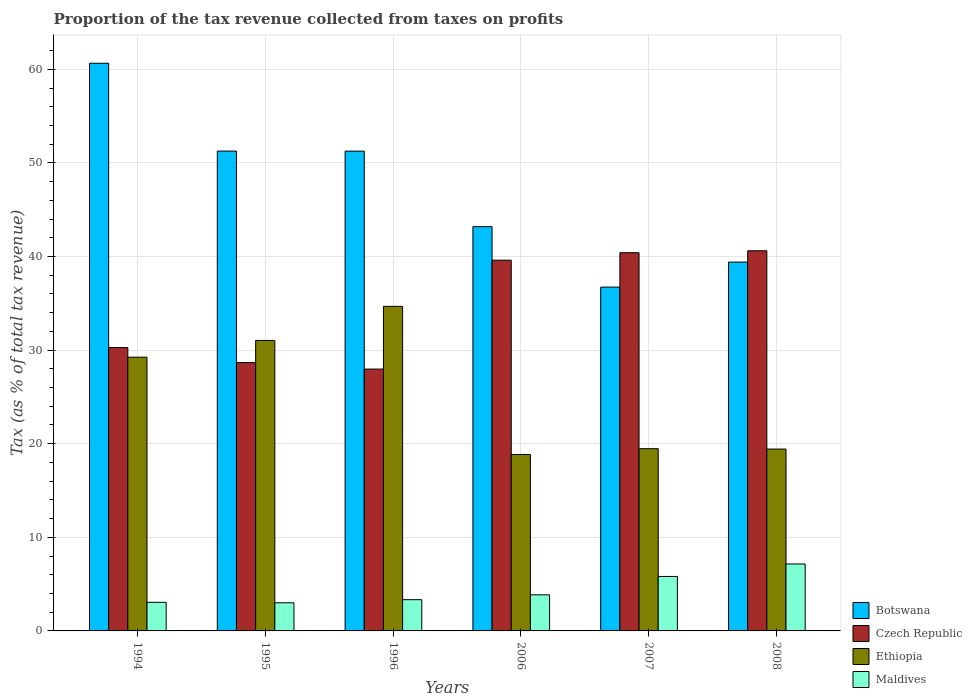How many groups of bars are there?
Give a very brief answer. 6. Are the number of bars per tick equal to the number of legend labels?
Give a very brief answer. Yes. How many bars are there on the 3rd tick from the left?
Offer a very short reply. 4. How many bars are there on the 3rd tick from the right?
Keep it short and to the point. 4. In how many cases, is the number of bars for a given year not equal to the number of legend labels?
Ensure brevity in your answer.  0. What is the proportion of the tax revenue collected in Ethiopia in 2006?
Provide a short and direct response. 18.85. Across all years, what is the maximum proportion of the tax revenue collected in Botswana?
Your answer should be very brief. 60.64. Across all years, what is the minimum proportion of the tax revenue collected in Maldives?
Offer a terse response. 3.01. In which year was the proportion of the tax revenue collected in Maldives maximum?
Make the answer very short. 2008. What is the total proportion of the tax revenue collected in Botswana in the graph?
Give a very brief answer. 282.48. What is the difference between the proportion of the tax revenue collected in Czech Republic in 1996 and that in 2006?
Ensure brevity in your answer.  -11.64. What is the difference between the proportion of the tax revenue collected in Maldives in 2008 and the proportion of the tax revenue collected in Ethiopia in 2006?
Provide a succinct answer. -11.7. What is the average proportion of the tax revenue collected in Ethiopia per year?
Ensure brevity in your answer.  25.45. In the year 1995, what is the difference between the proportion of the tax revenue collected in Ethiopia and proportion of the tax revenue collected in Botswana?
Make the answer very short. -20.23. What is the ratio of the proportion of the tax revenue collected in Ethiopia in 1994 to that in 1995?
Provide a short and direct response. 0.94. Is the proportion of the tax revenue collected in Czech Republic in 1994 less than that in 1996?
Provide a short and direct response. No. What is the difference between the highest and the second highest proportion of the tax revenue collected in Botswana?
Give a very brief answer. 9.38. What is the difference between the highest and the lowest proportion of the tax revenue collected in Czech Republic?
Provide a short and direct response. 12.64. Is the sum of the proportion of the tax revenue collected in Ethiopia in 1995 and 2006 greater than the maximum proportion of the tax revenue collected in Maldives across all years?
Provide a short and direct response. Yes. What does the 4th bar from the left in 2008 represents?
Your answer should be very brief. Maldives. What does the 1st bar from the right in 1994 represents?
Offer a terse response. Maldives. Is it the case that in every year, the sum of the proportion of the tax revenue collected in Maldives and proportion of the tax revenue collected in Czech Republic is greater than the proportion of the tax revenue collected in Ethiopia?
Provide a short and direct response. No. How many bars are there?
Make the answer very short. 24. How many years are there in the graph?
Your answer should be compact. 6. What is the difference between two consecutive major ticks on the Y-axis?
Ensure brevity in your answer.  10. Does the graph contain any zero values?
Provide a succinct answer. No. Does the graph contain grids?
Ensure brevity in your answer.  Yes. How many legend labels are there?
Offer a very short reply. 4. How are the legend labels stacked?
Your response must be concise. Vertical. What is the title of the graph?
Keep it short and to the point. Proportion of the tax revenue collected from taxes on profits. What is the label or title of the X-axis?
Offer a very short reply. Years. What is the label or title of the Y-axis?
Offer a very short reply. Tax (as % of total tax revenue). What is the Tax (as % of total tax revenue) in Botswana in 1994?
Provide a short and direct response. 60.64. What is the Tax (as % of total tax revenue) of Czech Republic in 1994?
Your response must be concise. 30.27. What is the Tax (as % of total tax revenue) of Ethiopia in 1994?
Your answer should be compact. 29.24. What is the Tax (as % of total tax revenue) in Maldives in 1994?
Offer a very short reply. 3.06. What is the Tax (as % of total tax revenue) in Botswana in 1995?
Make the answer very short. 51.26. What is the Tax (as % of total tax revenue) in Czech Republic in 1995?
Keep it short and to the point. 28.66. What is the Tax (as % of total tax revenue) in Ethiopia in 1995?
Offer a terse response. 31.03. What is the Tax (as % of total tax revenue) of Maldives in 1995?
Your answer should be very brief. 3.01. What is the Tax (as % of total tax revenue) in Botswana in 1996?
Give a very brief answer. 51.26. What is the Tax (as % of total tax revenue) in Czech Republic in 1996?
Ensure brevity in your answer.  27.97. What is the Tax (as % of total tax revenue) of Ethiopia in 1996?
Your answer should be compact. 34.67. What is the Tax (as % of total tax revenue) of Maldives in 1996?
Your answer should be compact. 3.34. What is the Tax (as % of total tax revenue) of Botswana in 2006?
Your answer should be compact. 43.19. What is the Tax (as % of total tax revenue) in Czech Republic in 2006?
Ensure brevity in your answer.  39.61. What is the Tax (as % of total tax revenue) in Ethiopia in 2006?
Provide a succinct answer. 18.85. What is the Tax (as % of total tax revenue) of Maldives in 2006?
Offer a very short reply. 3.86. What is the Tax (as % of total tax revenue) of Botswana in 2007?
Provide a succinct answer. 36.73. What is the Tax (as % of total tax revenue) of Czech Republic in 2007?
Your answer should be compact. 40.4. What is the Tax (as % of total tax revenue) in Ethiopia in 2007?
Make the answer very short. 19.47. What is the Tax (as % of total tax revenue) in Maldives in 2007?
Provide a short and direct response. 5.82. What is the Tax (as % of total tax revenue) in Botswana in 2008?
Keep it short and to the point. 39.4. What is the Tax (as % of total tax revenue) in Czech Republic in 2008?
Make the answer very short. 40.61. What is the Tax (as % of total tax revenue) of Ethiopia in 2008?
Your answer should be very brief. 19.43. What is the Tax (as % of total tax revenue) of Maldives in 2008?
Keep it short and to the point. 7.15. Across all years, what is the maximum Tax (as % of total tax revenue) in Botswana?
Your answer should be very brief. 60.64. Across all years, what is the maximum Tax (as % of total tax revenue) in Czech Republic?
Your answer should be compact. 40.61. Across all years, what is the maximum Tax (as % of total tax revenue) in Ethiopia?
Offer a very short reply. 34.67. Across all years, what is the maximum Tax (as % of total tax revenue) in Maldives?
Ensure brevity in your answer.  7.15. Across all years, what is the minimum Tax (as % of total tax revenue) of Botswana?
Ensure brevity in your answer.  36.73. Across all years, what is the minimum Tax (as % of total tax revenue) of Czech Republic?
Keep it short and to the point. 27.97. Across all years, what is the minimum Tax (as % of total tax revenue) of Ethiopia?
Give a very brief answer. 18.85. Across all years, what is the minimum Tax (as % of total tax revenue) in Maldives?
Offer a very short reply. 3.01. What is the total Tax (as % of total tax revenue) in Botswana in the graph?
Offer a terse response. 282.48. What is the total Tax (as % of total tax revenue) of Czech Republic in the graph?
Give a very brief answer. 207.53. What is the total Tax (as % of total tax revenue) in Ethiopia in the graph?
Your response must be concise. 152.69. What is the total Tax (as % of total tax revenue) in Maldives in the graph?
Offer a terse response. 26.23. What is the difference between the Tax (as % of total tax revenue) in Botswana in 1994 and that in 1995?
Your answer should be compact. 9.38. What is the difference between the Tax (as % of total tax revenue) in Czech Republic in 1994 and that in 1995?
Your response must be concise. 1.61. What is the difference between the Tax (as % of total tax revenue) in Ethiopia in 1994 and that in 1995?
Your answer should be very brief. -1.79. What is the difference between the Tax (as % of total tax revenue) of Maldives in 1994 and that in 1995?
Keep it short and to the point. 0.05. What is the difference between the Tax (as % of total tax revenue) in Botswana in 1994 and that in 1996?
Give a very brief answer. 9.39. What is the difference between the Tax (as % of total tax revenue) of Czech Republic in 1994 and that in 1996?
Your answer should be very brief. 2.3. What is the difference between the Tax (as % of total tax revenue) of Ethiopia in 1994 and that in 1996?
Ensure brevity in your answer.  -5.43. What is the difference between the Tax (as % of total tax revenue) of Maldives in 1994 and that in 1996?
Provide a short and direct response. -0.28. What is the difference between the Tax (as % of total tax revenue) of Botswana in 1994 and that in 2006?
Your answer should be very brief. 17.46. What is the difference between the Tax (as % of total tax revenue) in Czech Republic in 1994 and that in 2006?
Provide a succinct answer. -9.34. What is the difference between the Tax (as % of total tax revenue) of Ethiopia in 1994 and that in 2006?
Give a very brief answer. 10.39. What is the difference between the Tax (as % of total tax revenue) in Maldives in 1994 and that in 2006?
Your answer should be compact. -0.8. What is the difference between the Tax (as % of total tax revenue) of Botswana in 1994 and that in 2007?
Your answer should be very brief. 23.91. What is the difference between the Tax (as % of total tax revenue) in Czech Republic in 1994 and that in 2007?
Provide a short and direct response. -10.13. What is the difference between the Tax (as % of total tax revenue) in Ethiopia in 1994 and that in 2007?
Provide a short and direct response. 9.77. What is the difference between the Tax (as % of total tax revenue) in Maldives in 1994 and that in 2007?
Keep it short and to the point. -2.76. What is the difference between the Tax (as % of total tax revenue) in Botswana in 1994 and that in 2008?
Provide a succinct answer. 21.24. What is the difference between the Tax (as % of total tax revenue) in Czech Republic in 1994 and that in 2008?
Ensure brevity in your answer.  -10.34. What is the difference between the Tax (as % of total tax revenue) of Ethiopia in 1994 and that in 2008?
Provide a short and direct response. 9.81. What is the difference between the Tax (as % of total tax revenue) of Maldives in 1994 and that in 2008?
Your answer should be very brief. -4.09. What is the difference between the Tax (as % of total tax revenue) of Botswana in 1995 and that in 1996?
Give a very brief answer. 0.01. What is the difference between the Tax (as % of total tax revenue) in Czech Republic in 1995 and that in 1996?
Your answer should be compact. 0.69. What is the difference between the Tax (as % of total tax revenue) in Ethiopia in 1995 and that in 1996?
Keep it short and to the point. -3.64. What is the difference between the Tax (as % of total tax revenue) in Maldives in 1995 and that in 1996?
Ensure brevity in your answer.  -0.33. What is the difference between the Tax (as % of total tax revenue) of Botswana in 1995 and that in 2006?
Offer a terse response. 8.07. What is the difference between the Tax (as % of total tax revenue) in Czech Republic in 1995 and that in 2006?
Your response must be concise. -10.94. What is the difference between the Tax (as % of total tax revenue) in Ethiopia in 1995 and that in 2006?
Ensure brevity in your answer.  12.18. What is the difference between the Tax (as % of total tax revenue) of Maldives in 1995 and that in 2006?
Provide a short and direct response. -0.85. What is the difference between the Tax (as % of total tax revenue) in Botswana in 1995 and that in 2007?
Your answer should be compact. 14.53. What is the difference between the Tax (as % of total tax revenue) of Czech Republic in 1995 and that in 2007?
Offer a terse response. -11.74. What is the difference between the Tax (as % of total tax revenue) in Ethiopia in 1995 and that in 2007?
Keep it short and to the point. 11.56. What is the difference between the Tax (as % of total tax revenue) of Maldives in 1995 and that in 2007?
Provide a succinct answer. -2.81. What is the difference between the Tax (as % of total tax revenue) in Botswana in 1995 and that in 2008?
Give a very brief answer. 11.86. What is the difference between the Tax (as % of total tax revenue) of Czech Republic in 1995 and that in 2008?
Your answer should be very brief. -11.95. What is the difference between the Tax (as % of total tax revenue) of Ethiopia in 1995 and that in 2008?
Offer a terse response. 11.6. What is the difference between the Tax (as % of total tax revenue) in Maldives in 1995 and that in 2008?
Give a very brief answer. -4.15. What is the difference between the Tax (as % of total tax revenue) in Botswana in 1996 and that in 2006?
Offer a terse response. 8.07. What is the difference between the Tax (as % of total tax revenue) of Czech Republic in 1996 and that in 2006?
Your answer should be very brief. -11.64. What is the difference between the Tax (as % of total tax revenue) in Ethiopia in 1996 and that in 2006?
Make the answer very short. 15.82. What is the difference between the Tax (as % of total tax revenue) in Maldives in 1996 and that in 2006?
Offer a terse response. -0.52. What is the difference between the Tax (as % of total tax revenue) in Botswana in 1996 and that in 2007?
Keep it short and to the point. 14.53. What is the difference between the Tax (as % of total tax revenue) of Czech Republic in 1996 and that in 2007?
Provide a short and direct response. -12.43. What is the difference between the Tax (as % of total tax revenue) in Ethiopia in 1996 and that in 2007?
Ensure brevity in your answer.  15.21. What is the difference between the Tax (as % of total tax revenue) in Maldives in 1996 and that in 2007?
Provide a short and direct response. -2.48. What is the difference between the Tax (as % of total tax revenue) of Botswana in 1996 and that in 2008?
Ensure brevity in your answer.  11.85. What is the difference between the Tax (as % of total tax revenue) in Czech Republic in 1996 and that in 2008?
Provide a succinct answer. -12.64. What is the difference between the Tax (as % of total tax revenue) in Ethiopia in 1996 and that in 2008?
Provide a succinct answer. 15.24. What is the difference between the Tax (as % of total tax revenue) of Maldives in 1996 and that in 2008?
Ensure brevity in your answer.  -3.81. What is the difference between the Tax (as % of total tax revenue) of Botswana in 2006 and that in 2007?
Your answer should be compact. 6.46. What is the difference between the Tax (as % of total tax revenue) in Czech Republic in 2006 and that in 2007?
Your answer should be compact. -0.79. What is the difference between the Tax (as % of total tax revenue) of Ethiopia in 2006 and that in 2007?
Offer a very short reply. -0.62. What is the difference between the Tax (as % of total tax revenue) of Maldives in 2006 and that in 2007?
Make the answer very short. -1.96. What is the difference between the Tax (as % of total tax revenue) of Botswana in 2006 and that in 2008?
Your response must be concise. 3.78. What is the difference between the Tax (as % of total tax revenue) in Czech Republic in 2006 and that in 2008?
Make the answer very short. -1. What is the difference between the Tax (as % of total tax revenue) in Ethiopia in 2006 and that in 2008?
Make the answer very short. -0.58. What is the difference between the Tax (as % of total tax revenue) of Maldives in 2006 and that in 2008?
Offer a very short reply. -3.3. What is the difference between the Tax (as % of total tax revenue) in Botswana in 2007 and that in 2008?
Provide a short and direct response. -2.67. What is the difference between the Tax (as % of total tax revenue) in Czech Republic in 2007 and that in 2008?
Your answer should be compact. -0.21. What is the difference between the Tax (as % of total tax revenue) in Ethiopia in 2007 and that in 2008?
Your answer should be compact. 0.04. What is the difference between the Tax (as % of total tax revenue) in Maldives in 2007 and that in 2008?
Provide a succinct answer. -1.33. What is the difference between the Tax (as % of total tax revenue) in Botswana in 1994 and the Tax (as % of total tax revenue) in Czech Republic in 1995?
Offer a terse response. 31.98. What is the difference between the Tax (as % of total tax revenue) of Botswana in 1994 and the Tax (as % of total tax revenue) of Ethiopia in 1995?
Ensure brevity in your answer.  29.61. What is the difference between the Tax (as % of total tax revenue) in Botswana in 1994 and the Tax (as % of total tax revenue) in Maldives in 1995?
Offer a terse response. 57.64. What is the difference between the Tax (as % of total tax revenue) in Czech Republic in 1994 and the Tax (as % of total tax revenue) in Ethiopia in 1995?
Give a very brief answer. -0.76. What is the difference between the Tax (as % of total tax revenue) of Czech Republic in 1994 and the Tax (as % of total tax revenue) of Maldives in 1995?
Provide a short and direct response. 27.26. What is the difference between the Tax (as % of total tax revenue) in Ethiopia in 1994 and the Tax (as % of total tax revenue) in Maldives in 1995?
Offer a terse response. 26.23. What is the difference between the Tax (as % of total tax revenue) of Botswana in 1994 and the Tax (as % of total tax revenue) of Czech Republic in 1996?
Make the answer very short. 32.67. What is the difference between the Tax (as % of total tax revenue) in Botswana in 1994 and the Tax (as % of total tax revenue) in Ethiopia in 1996?
Ensure brevity in your answer.  25.97. What is the difference between the Tax (as % of total tax revenue) in Botswana in 1994 and the Tax (as % of total tax revenue) in Maldives in 1996?
Keep it short and to the point. 57.31. What is the difference between the Tax (as % of total tax revenue) of Czech Republic in 1994 and the Tax (as % of total tax revenue) of Ethiopia in 1996?
Keep it short and to the point. -4.4. What is the difference between the Tax (as % of total tax revenue) in Czech Republic in 1994 and the Tax (as % of total tax revenue) in Maldives in 1996?
Give a very brief answer. 26.93. What is the difference between the Tax (as % of total tax revenue) of Ethiopia in 1994 and the Tax (as % of total tax revenue) of Maldives in 1996?
Offer a very short reply. 25.9. What is the difference between the Tax (as % of total tax revenue) in Botswana in 1994 and the Tax (as % of total tax revenue) in Czech Republic in 2006?
Make the answer very short. 21.03. What is the difference between the Tax (as % of total tax revenue) in Botswana in 1994 and the Tax (as % of total tax revenue) in Ethiopia in 2006?
Give a very brief answer. 41.79. What is the difference between the Tax (as % of total tax revenue) of Botswana in 1994 and the Tax (as % of total tax revenue) of Maldives in 2006?
Make the answer very short. 56.79. What is the difference between the Tax (as % of total tax revenue) in Czech Republic in 1994 and the Tax (as % of total tax revenue) in Ethiopia in 2006?
Make the answer very short. 11.42. What is the difference between the Tax (as % of total tax revenue) of Czech Republic in 1994 and the Tax (as % of total tax revenue) of Maldives in 2006?
Keep it short and to the point. 26.41. What is the difference between the Tax (as % of total tax revenue) of Ethiopia in 1994 and the Tax (as % of total tax revenue) of Maldives in 2006?
Your answer should be very brief. 25.39. What is the difference between the Tax (as % of total tax revenue) of Botswana in 1994 and the Tax (as % of total tax revenue) of Czech Republic in 2007?
Give a very brief answer. 20.24. What is the difference between the Tax (as % of total tax revenue) of Botswana in 1994 and the Tax (as % of total tax revenue) of Ethiopia in 2007?
Make the answer very short. 41.18. What is the difference between the Tax (as % of total tax revenue) of Botswana in 1994 and the Tax (as % of total tax revenue) of Maldives in 2007?
Provide a short and direct response. 54.83. What is the difference between the Tax (as % of total tax revenue) of Czech Republic in 1994 and the Tax (as % of total tax revenue) of Ethiopia in 2007?
Ensure brevity in your answer.  10.8. What is the difference between the Tax (as % of total tax revenue) in Czech Republic in 1994 and the Tax (as % of total tax revenue) in Maldives in 2007?
Keep it short and to the point. 24.45. What is the difference between the Tax (as % of total tax revenue) of Ethiopia in 1994 and the Tax (as % of total tax revenue) of Maldives in 2007?
Keep it short and to the point. 23.42. What is the difference between the Tax (as % of total tax revenue) of Botswana in 1994 and the Tax (as % of total tax revenue) of Czech Republic in 2008?
Your answer should be very brief. 20.03. What is the difference between the Tax (as % of total tax revenue) in Botswana in 1994 and the Tax (as % of total tax revenue) in Ethiopia in 2008?
Your answer should be very brief. 41.21. What is the difference between the Tax (as % of total tax revenue) in Botswana in 1994 and the Tax (as % of total tax revenue) in Maldives in 2008?
Offer a very short reply. 53.49. What is the difference between the Tax (as % of total tax revenue) in Czech Republic in 1994 and the Tax (as % of total tax revenue) in Ethiopia in 2008?
Your answer should be compact. 10.84. What is the difference between the Tax (as % of total tax revenue) in Czech Republic in 1994 and the Tax (as % of total tax revenue) in Maldives in 2008?
Give a very brief answer. 23.12. What is the difference between the Tax (as % of total tax revenue) in Ethiopia in 1994 and the Tax (as % of total tax revenue) in Maldives in 2008?
Provide a short and direct response. 22.09. What is the difference between the Tax (as % of total tax revenue) in Botswana in 1995 and the Tax (as % of total tax revenue) in Czech Republic in 1996?
Ensure brevity in your answer.  23.29. What is the difference between the Tax (as % of total tax revenue) of Botswana in 1995 and the Tax (as % of total tax revenue) of Ethiopia in 1996?
Your answer should be very brief. 16.59. What is the difference between the Tax (as % of total tax revenue) in Botswana in 1995 and the Tax (as % of total tax revenue) in Maldives in 1996?
Offer a terse response. 47.92. What is the difference between the Tax (as % of total tax revenue) of Czech Republic in 1995 and the Tax (as % of total tax revenue) of Ethiopia in 1996?
Keep it short and to the point. -6.01. What is the difference between the Tax (as % of total tax revenue) of Czech Republic in 1995 and the Tax (as % of total tax revenue) of Maldives in 1996?
Your answer should be compact. 25.33. What is the difference between the Tax (as % of total tax revenue) of Ethiopia in 1995 and the Tax (as % of total tax revenue) of Maldives in 1996?
Your answer should be compact. 27.69. What is the difference between the Tax (as % of total tax revenue) of Botswana in 1995 and the Tax (as % of total tax revenue) of Czech Republic in 2006?
Give a very brief answer. 11.65. What is the difference between the Tax (as % of total tax revenue) of Botswana in 1995 and the Tax (as % of total tax revenue) of Ethiopia in 2006?
Offer a very short reply. 32.41. What is the difference between the Tax (as % of total tax revenue) in Botswana in 1995 and the Tax (as % of total tax revenue) in Maldives in 2006?
Make the answer very short. 47.41. What is the difference between the Tax (as % of total tax revenue) in Czech Republic in 1995 and the Tax (as % of total tax revenue) in Ethiopia in 2006?
Offer a terse response. 9.82. What is the difference between the Tax (as % of total tax revenue) in Czech Republic in 1995 and the Tax (as % of total tax revenue) in Maldives in 2006?
Offer a terse response. 24.81. What is the difference between the Tax (as % of total tax revenue) of Ethiopia in 1995 and the Tax (as % of total tax revenue) of Maldives in 2006?
Keep it short and to the point. 27.18. What is the difference between the Tax (as % of total tax revenue) in Botswana in 1995 and the Tax (as % of total tax revenue) in Czech Republic in 2007?
Provide a succinct answer. 10.86. What is the difference between the Tax (as % of total tax revenue) in Botswana in 1995 and the Tax (as % of total tax revenue) in Ethiopia in 2007?
Make the answer very short. 31.79. What is the difference between the Tax (as % of total tax revenue) in Botswana in 1995 and the Tax (as % of total tax revenue) in Maldives in 2007?
Your response must be concise. 45.44. What is the difference between the Tax (as % of total tax revenue) in Czech Republic in 1995 and the Tax (as % of total tax revenue) in Ethiopia in 2007?
Your response must be concise. 9.2. What is the difference between the Tax (as % of total tax revenue) in Czech Republic in 1995 and the Tax (as % of total tax revenue) in Maldives in 2007?
Your answer should be very brief. 22.85. What is the difference between the Tax (as % of total tax revenue) in Ethiopia in 1995 and the Tax (as % of total tax revenue) in Maldives in 2007?
Your response must be concise. 25.21. What is the difference between the Tax (as % of total tax revenue) of Botswana in 1995 and the Tax (as % of total tax revenue) of Czech Republic in 2008?
Provide a short and direct response. 10.65. What is the difference between the Tax (as % of total tax revenue) of Botswana in 1995 and the Tax (as % of total tax revenue) of Ethiopia in 2008?
Offer a terse response. 31.83. What is the difference between the Tax (as % of total tax revenue) in Botswana in 1995 and the Tax (as % of total tax revenue) in Maldives in 2008?
Your answer should be compact. 44.11. What is the difference between the Tax (as % of total tax revenue) in Czech Republic in 1995 and the Tax (as % of total tax revenue) in Ethiopia in 2008?
Provide a succinct answer. 9.23. What is the difference between the Tax (as % of total tax revenue) in Czech Republic in 1995 and the Tax (as % of total tax revenue) in Maldives in 2008?
Offer a terse response. 21.51. What is the difference between the Tax (as % of total tax revenue) of Ethiopia in 1995 and the Tax (as % of total tax revenue) of Maldives in 2008?
Provide a succinct answer. 23.88. What is the difference between the Tax (as % of total tax revenue) in Botswana in 1996 and the Tax (as % of total tax revenue) in Czech Republic in 2006?
Your answer should be very brief. 11.65. What is the difference between the Tax (as % of total tax revenue) of Botswana in 1996 and the Tax (as % of total tax revenue) of Ethiopia in 2006?
Offer a terse response. 32.41. What is the difference between the Tax (as % of total tax revenue) in Botswana in 1996 and the Tax (as % of total tax revenue) in Maldives in 2006?
Ensure brevity in your answer.  47.4. What is the difference between the Tax (as % of total tax revenue) of Czech Republic in 1996 and the Tax (as % of total tax revenue) of Ethiopia in 2006?
Your answer should be very brief. 9.12. What is the difference between the Tax (as % of total tax revenue) in Czech Republic in 1996 and the Tax (as % of total tax revenue) in Maldives in 2006?
Offer a terse response. 24.12. What is the difference between the Tax (as % of total tax revenue) in Ethiopia in 1996 and the Tax (as % of total tax revenue) in Maldives in 2006?
Give a very brief answer. 30.82. What is the difference between the Tax (as % of total tax revenue) in Botswana in 1996 and the Tax (as % of total tax revenue) in Czech Republic in 2007?
Your answer should be very brief. 10.85. What is the difference between the Tax (as % of total tax revenue) in Botswana in 1996 and the Tax (as % of total tax revenue) in Ethiopia in 2007?
Your answer should be compact. 31.79. What is the difference between the Tax (as % of total tax revenue) of Botswana in 1996 and the Tax (as % of total tax revenue) of Maldives in 2007?
Make the answer very short. 45.44. What is the difference between the Tax (as % of total tax revenue) of Czech Republic in 1996 and the Tax (as % of total tax revenue) of Ethiopia in 2007?
Offer a very short reply. 8.51. What is the difference between the Tax (as % of total tax revenue) of Czech Republic in 1996 and the Tax (as % of total tax revenue) of Maldives in 2007?
Offer a very short reply. 22.16. What is the difference between the Tax (as % of total tax revenue) of Ethiopia in 1996 and the Tax (as % of total tax revenue) of Maldives in 2007?
Give a very brief answer. 28.86. What is the difference between the Tax (as % of total tax revenue) of Botswana in 1996 and the Tax (as % of total tax revenue) of Czech Republic in 2008?
Provide a succinct answer. 10.65. What is the difference between the Tax (as % of total tax revenue) in Botswana in 1996 and the Tax (as % of total tax revenue) in Ethiopia in 2008?
Give a very brief answer. 31.83. What is the difference between the Tax (as % of total tax revenue) in Botswana in 1996 and the Tax (as % of total tax revenue) in Maldives in 2008?
Offer a terse response. 44.1. What is the difference between the Tax (as % of total tax revenue) in Czech Republic in 1996 and the Tax (as % of total tax revenue) in Ethiopia in 2008?
Give a very brief answer. 8.54. What is the difference between the Tax (as % of total tax revenue) in Czech Republic in 1996 and the Tax (as % of total tax revenue) in Maldives in 2008?
Give a very brief answer. 20.82. What is the difference between the Tax (as % of total tax revenue) in Ethiopia in 1996 and the Tax (as % of total tax revenue) in Maldives in 2008?
Offer a very short reply. 27.52. What is the difference between the Tax (as % of total tax revenue) in Botswana in 2006 and the Tax (as % of total tax revenue) in Czech Republic in 2007?
Make the answer very short. 2.78. What is the difference between the Tax (as % of total tax revenue) of Botswana in 2006 and the Tax (as % of total tax revenue) of Ethiopia in 2007?
Your answer should be very brief. 23.72. What is the difference between the Tax (as % of total tax revenue) of Botswana in 2006 and the Tax (as % of total tax revenue) of Maldives in 2007?
Ensure brevity in your answer.  37.37. What is the difference between the Tax (as % of total tax revenue) in Czech Republic in 2006 and the Tax (as % of total tax revenue) in Ethiopia in 2007?
Offer a very short reply. 20.14. What is the difference between the Tax (as % of total tax revenue) in Czech Republic in 2006 and the Tax (as % of total tax revenue) in Maldives in 2007?
Ensure brevity in your answer.  33.79. What is the difference between the Tax (as % of total tax revenue) of Ethiopia in 2006 and the Tax (as % of total tax revenue) of Maldives in 2007?
Give a very brief answer. 13.03. What is the difference between the Tax (as % of total tax revenue) in Botswana in 2006 and the Tax (as % of total tax revenue) in Czech Republic in 2008?
Keep it short and to the point. 2.58. What is the difference between the Tax (as % of total tax revenue) in Botswana in 2006 and the Tax (as % of total tax revenue) in Ethiopia in 2008?
Ensure brevity in your answer.  23.76. What is the difference between the Tax (as % of total tax revenue) of Botswana in 2006 and the Tax (as % of total tax revenue) of Maldives in 2008?
Keep it short and to the point. 36.04. What is the difference between the Tax (as % of total tax revenue) of Czech Republic in 2006 and the Tax (as % of total tax revenue) of Ethiopia in 2008?
Give a very brief answer. 20.18. What is the difference between the Tax (as % of total tax revenue) of Czech Republic in 2006 and the Tax (as % of total tax revenue) of Maldives in 2008?
Offer a terse response. 32.46. What is the difference between the Tax (as % of total tax revenue) of Ethiopia in 2006 and the Tax (as % of total tax revenue) of Maldives in 2008?
Your answer should be very brief. 11.7. What is the difference between the Tax (as % of total tax revenue) in Botswana in 2007 and the Tax (as % of total tax revenue) in Czech Republic in 2008?
Your answer should be very brief. -3.88. What is the difference between the Tax (as % of total tax revenue) in Botswana in 2007 and the Tax (as % of total tax revenue) in Ethiopia in 2008?
Ensure brevity in your answer.  17.3. What is the difference between the Tax (as % of total tax revenue) in Botswana in 2007 and the Tax (as % of total tax revenue) in Maldives in 2008?
Make the answer very short. 29.58. What is the difference between the Tax (as % of total tax revenue) of Czech Republic in 2007 and the Tax (as % of total tax revenue) of Ethiopia in 2008?
Provide a short and direct response. 20.97. What is the difference between the Tax (as % of total tax revenue) in Czech Republic in 2007 and the Tax (as % of total tax revenue) in Maldives in 2008?
Ensure brevity in your answer.  33.25. What is the difference between the Tax (as % of total tax revenue) in Ethiopia in 2007 and the Tax (as % of total tax revenue) in Maldives in 2008?
Provide a short and direct response. 12.32. What is the average Tax (as % of total tax revenue) in Botswana per year?
Your answer should be compact. 47.08. What is the average Tax (as % of total tax revenue) of Czech Republic per year?
Provide a short and direct response. 34.59. What is the average Tax (as % of total tax revenue) in Ethiopia per year?
Your answer should be very brief. 25.45. What is the average Tax (as % of total tax revenue) in Maldives per year?
Your answer should be compact. 4.37. In the year 1994, what is the difference between the Tax (as % of total tax revenue) in Botswana and Tax (as % of total tax revenue) in Czech Republic?
Provide a short and direct response. 30.37. In the year 1994, what is the difference between the Tax (as % of total tax revenue) in Botswana and Tax (as % of total tax revenue) in Ethiopia?
Make the answer very short. 31.4. In the year 1994, what is the difference between the Tax (as % of total tax revenue) of Botswana and Tax (as % of total tax revenue) of Maldives?
Ensure brevity in your answer.  57.59. In the year 1994, what is the difference between the Tax (as % of total tax revenue) of Czech Republic and Tax (as % of total tax revenue) of Ethiopia?
Ensure brevity in your answer.  1.03. In the year 1994, what is the difference between the Tax (as % of total tax revenue) of Czech Republic and Tax (as % of total tax revenue) of Maldives?
Your answer should be very brief. 27.21. In the year 1994, what is the difference between the Tax (as % of total tax revenue) in Ethiopia and Tax (as % of total tax revenue) in Maldives?
Your answer should be very brief. 26.18. In the year 1995, what is the difference between the Tax (as % of total tax revenue) in Botswana and Tax (as % of total tax revenue) in Czech Republic?
Provide a short and direct response. 22.6. In the year 1995, what is the difference between the Tax (as % of total tax revenue) of Botswana and Tax (as % of total tax revenue) of Ethiopia?
Offer a terse response. 20.23. In the year 1995, what is the difference between the Tax (as % of total tax revenue) in Botswana and Tax (as % of total tax revenue) in Maldives?
Make the answer very short. 48.26. In the year 1995, what is the difference between the Tax (as % of total tax revenue) of Czech Republic and Tax (as % of total tax revenue) of Ethiopia?
Offer a terse response. -2.37. In the year 1995, what is the difference between the Tax (as % of total tax revenue) of Czech Republic and Tax (as % of total tax revenue) of Maldives?
Provide a succinct answer. 25.66. In the year 1995, what is the difference between the Tax (as % of total tax revenue) in Ethiopia and Tax (as % of total tax revenue) in Maldives?
Offer a very short reply. 28.02. In the year 1996, what is the difference between the Tax (as % of total tax revenue) in Botswana and Tax (as % of total tax revenue) in Czech Republic?
Offer a very short reply. 23.28. In the year 1996, what is the difference between the Tax (as % of total tax revenue) of Botswana and Tax (as % of total tax revenue) of Ethiopia?
Your answer should be very brief. 16.58. In the year 1996, what is the difference between the Tax (as % of total tax revenue) in Botswana and Tax (as % of total tax revenue) in Maldives?
Your answer should be compact. 47.92. In the year 1996, what is the difference between the Tax (as % of total tax revenue) in Czech Republic and Tax (as % of total tax revenue) in Maldives?
Offer a very short reply. 24.64. In the year 1996, what is the difference between the Tax (as % of total tax revenue) in Ethiopia and Tax (as % of total tax revenue) in Maldives?
Provide a succinct answer. 31.34. In the year 2006, what is the difference between the Tax (as % of total tax revenue) in Botswana and Tax (as % of total tax revenue) in Czech Republic?
Provide a short and direct response. 3.58. In the year 2006, what is the difference between the Tax (as % of total tax revenue) of Botswana and Tax (as % of total tax revenue) of Ethiopia?
Offer a terse response. 24.34. In the year 2006, what is the difference between the Tax (as % of total tax revenue) in Botswana and Tax (as % of total tax revenue) in Maldives?
Your response must be concise. 39.33. In the year 2006, what is the difference between the Tax (as % of total tax revenue) of Czech Republic and Tax (as % of total tax revenue) of Ethiopia?
Ensure brevity in your answer.  20.76. In the year 2006, what is the difference between the Tax (as % of total tax revenue) in Czech Republic and Tax (as % of total tax revenue) in Maldives?
Ensure brevity in your answer.  35.75. In the year 2006, what is the difference between the Tax (as % of total tax revenue) in Ethiopia and Tax (as % of total tax revenue) in Maldives?
Your response must be concise. 14.99. In the year 2007, what is the difference between the Tax (as % of total tax revenue) of Botswana and Tax (as % of total tax revenue) of Czech Republic?
Offer a very short reply. -3.67. In the year 2007, what is the difference between the Tax (as % of total tax revenue) of Botswana and Tax (as % of total tax revenue) of Ethiopia?
Your answer should be compact. 17.26. In the year 2007, what is the difference between the Tax (as % of total tax revenue) of Botswana and Tax (as % of total tax revenue) of Maldives?
Make the answer very short. 30.91. In the year 2007, what is the difference between the Tax (as % of total tax revenue) in Czech Republic and Tax (as % of total tax revenue) in Ethiopia?
Keep it short and to the point. 20.94. In the year 2007, what is the difference between the Tax (as % of total tax revenue) of Czech Republic and Tax (as % of total tax revenue) of Maldives?
Give a very brief answer. 34.59. In the year 2007, what is the difference between the Tax (as % of total tax revenue) in Ethiopia and Tax (as % of total tax revenue) in Maldives?
Offer a terse response. 13.65. In the year 2008, what is the difference between the Tax (as % of total tax revenue) of Botswana and Tax (as % of total tax revenue) of Czech Republic?
Your response must be concise. -1.21. In the year 2008, what is the difference between the Tax (as % of total tax revenue) in Botswana and Tax (as % of total tax revenue) in Ethiopia?
Offer a very short reply. 19.97. In the year 2008, what is the difference between the Tax (as % of total tax revenue) of Botswana and Tax (as % of total tax revenue) of Maldives?
Provide a succinct answer. 32.25. In the year 2008, what is the difference between the Tax (as % of total tax revenue) in Czech Republic and Tax (as % of total tax revenue) in Ethiopia?
Your answer should be compact. 21.18. In the year 2008, what is the difference between the Tax (as % of total tax revenue) of Czech Republic and Tax (as % of total tax revenue) of Maldives?
Your response must be concise. 33.46. In the year 2008, what is the difference between the Tax (as % of total tax revenue) of Ethiopia and Tax (as % of total tax revenue) of Maldives?
Your response must be concise. 12.28. What is the ratio of the Tax (as % of total tax revenue) of Botswana in 1994 to that in 1995?
Give a very brief answer. 1.18. What is the ratio of the Tax (as % of total tax revenue) in Czech Republic in 1994 to that in 1995?
Offer a very short reply. 1.06. What is the ratio of the Tax (as % of total tax revenue) in Ethiopia in 1994 to that in 1995?
Make the answer very short. 0.94. What is the ratio of the Tax (as % of total tax revenue) of Maldives in 1994 to that in 1995?
Your response must be concise. 1.02. What is the ratio of the Tax (as % of total tax revenue) in Botswana in 1994 to that in 1996?
Your response must be concise. 1.18. What is the ratio of the Tax (as % of total tax revenue) in Czech Republic in 1994 to that in 1996?
Offer a very short reply. 1.08. What is the ratio of the Tax (as % of total tax revenue) in Ethiopia in 1994 to that in 1996?
Keep it short and to the point. 0.84. What is the ratio of the Tax (as % of total tax revenue) in Maldives in 1994 to that in 1996?
Offer a terse response. 0.92. What is the ratio of the Tax (as % of total tax revenue) of Botswana in 1994 to that in 2006?
Provide a succinct answer. 1.4. What is the ratio of the Tax (as % of total tax revenue) of Czech Republic in 1994 to that in 2006?
Your answer should be compact. 0.76. What is the ratio of the Tax (as % of total tax revenue) of Ethiopia in 1994 to that in 2006?
Your answer should be very brief. 1.55. What is the ratio of the Tax (as % of total tax revenue) of Maldives in 1994 to that in 2006?
Your answer should be compact. 0.79. What is the ratio of the Tax (as % of total tax revenue) in Botswana in 1994 to that in 2007?
Offer a terse response. 1.65. What is the ratio of the Tax (as % of total tax revenue) in Czech Republic in 1994 to that in 2007?
Your answer should be compact. 0.75. What is the ratio of the Tax (as % of total tax revenue) of Ethiopia in 1994 to that in 2007?
Offer a very short reply. 1.5. What is the ratio of the Tax (as % of total tax revenue) in Maldives in 1994 to that in 2007?
Provide a succinct answer. 0.53. What is the ratio of the Tax (as % of total tax revenue) of Botswana in 1994 to that in 2008?
Make the answer very short. 1.54. What is the ratio of the Tax (as % of total tax revenue) of Czech Republic in 1994 to that in 2008?
Make the answer very short. 0.75. What is the ratio of the Tax (as % of total tax revenue) in Ethiopia in 1994 to that in 2008?
Ensure brevity in your answer.  1.5. What is the ratio of the Tax (as % of total tax revenue) in Maldives in 1994 to that in 2008?
Offer a terse response. 0.43. What is the ratio of the Tax (as % of total tax revenue) of Czech Republic in 1995 to that in 1996?
Offer a very short reply. 1.02. What is the ratio of the Tax (as % of total tax revenue) of Ethiopia in 1995 to that in 1996?
Ensure brevity in your answer.  0.9. What is the ratio of the Tax (as % of total tax revenue) in Maldives in 1995 to that in 1996?
Give a very brief answer. 0.9. What is the ratio of the Tax (as % of total tax revenue) in Botswana in 1995 to that in 2006?
Give a very brief answer. 1.19. What is the ratio of the Tax (as % of total tax revenue) of Czech Republic in 1995 to that in 2006?
Offer a terse response. 0.72. What is the ratio of the Tax (as % of total tax revenue) in Ethiopia in 1995 to that in 2006?
Provide a short and direct response. 1.65. What is the ratio of the Tax (as % of total tax revenue) of Maldives in 1995 to that in 2006?
Your answer should be very brief. 0.78. What is the ratio of the Tax (as % of total tax revenue) of Botswana in 1995 to that in 2007?
Keep it short and to the point. 1.4. What is the ratio of the Tax (as % of total tax revenue) in Czech Republic in 1995 to that in 2007?
Give a very brief answer. 0.71. What is the ratio of the Tax (as % of total tax revenue) of Ethiopia in 1995 to that in 2007?
Your answer should be very brief. 1.59. What is the ratio of the Tax (as % of total tax revenue) in Maldives in 1995 to that in 2007?
Provide a succinct answer. 0.52. What is the ratio of the Tax (as % of total tax revenue) of Botswana in 1995 to that in 2008?
Give a very brief answer. 1.3. What is the ratio of the Tax (as % of total tax revenue) in Czech Republic in 1995 to that in 2008?
Ensure brevity in your answer.  0.71. What is the ratio of the Tax (as % of total tax revenue) in Ethiopia in 1995 to that in 2008?
Make the answer very short. 1.6. What is the ratio of the Tax (as % of total tax revenue) in Maldives in 1995 to that in 2008?
Your answer should be very brief. 0.42. What is the ratio of the Tax (as % of total tax revenue) in Botswana in 1996 to that in 2006?
Give a very brief answer. 1.19. What is the ratio of the Tax (as % of total tax revenue) of Czech Republic in 1996 to that in 2006?
Your answer should be compact. 0.71. What is the ratio of the Tax (as % of total tax revenue) in Ethiopia in 1996 to that in 2006?
Provide a succinct answer. 1.84. What is the ratio of the Tax (as % of total tax revenue) in Maldives in 1996 to that in 2006?
Your response must be concise. 0.87. What is the ratio of the Tax (as % of total tax revenue) of Botswana in 1996 to that in 2007?
Provide a succinct answer. 1.4. What is the ratio of the Tax (as % of total tax revenue) in Czech Republic in 1996 to that in 2007?
Your response must be concise. 0.69. What is the ratio of the Tax (as % of total tax revenue) of Ethiopia in 1996 to that in 2007?
Ensure brevity in your answer.  1.78. What is the ratio of the Tax (as % of total tax revenue) of Maldives in 1996 to that in 2007?
Your response must be concise. 0.57. What is the ratio of the Tax (as % of total tax revenue) in Botswana in 1996 to that in 2008?
Your answer should be very brief. 1.3. What is the ratio of the Tax (as % of total tax revenue) of Czech Republic in 1996 to that in 2008?
Offer a very short reply. 0.69. What is the ratio of the Tax (as % of total tax revenue) in Ethiopia in 1996 to that in 2008?
Provide a succinct answer. 1.78. What is the ratio of the Tax (as % of total tax revenue) in Maldives in 1996 to that in 2008?
Offer a very short reply. 0.47. What is the ratio of the Tax (as % of total tax revenue) in Botswana in 2006 to that in 2007?
Offer a terse response. 1.18. What is the ratio of the Tax (as % of total tax revenue) of Czech Republic in 2006 to that in 2007?
Offer a very short reply. 0.98. What is the ratio of the Tax (as % of total tax revenue) of Ethiopia in 2006 to that in 2007?
Make the answer very short. 0.97. What is the ratio of the Tax (as % of total tax revenue) of Maldives in 2006 to that in 2007?
Your response must be concise. 0.66. What is the ratio of the Tax (as % of total tax revenue) of Botswana in 2006 to that in 2008?
Your response must be concise. 1.1. What is the ratio of the Tax (as % of total tax revenue) in Czech Republic in 2006 to that in 2008?
Provide a short and direct response. 0.98. What is the ratio of the Tax (as % of total tax revenue) of Ethiopia in 2006 to that in 2008?
Offer a terse response. 0.97. What is the ratio of the Tax (as % of total tax revenue) of Maldives in 2006 to that in 2008?
Provide a succinct answer. 0.54. What is the ratio of the Tax (as % of total tax revenue) of Botswana in 2007 to that in 2008?
Provide a succinct answer. 0.93. What is the ratio of the Tax (as % of total tax revenue) in Czech Republic in 2007 to that in 2008?
Your response must be concise. 0.99. What is the ratio of the Tax (as % of total tax revenue) in Ethiopia in 2007 to that in 2008?
Your answer should be compact. 1. What is the ratio of the Tax (as % of total tax revenue) in Maldives in 2007 to that in 2008?
Keep it short and to the point. 0.81. What is the difference between the highest and the second highest Tax (as % of total tax revenue) of Botswana?
Give a very brief answer. 9.38. What is the difference between the highest and the second highest Tax (as % of total tax revenue) in Czech Republic?
Your answer should be very brief. 0.21. What is the difference between the highest and the second highest Tax (as % of total tax revenue) in Ethiopia?
Offer a terse response. 3.64. What is the difference between the highest and the second highest Tax (as % of total tax revenue) in Maldives?
Provide a short and direct response. 1.33. What is the difference between the highest and the lowest Tax (as % of total tax revenue) in Botswana?
Ensure brevity in your answer.  23.91. What is the difference between the highest and the lowest Tax (as % of total tax revenue) of Czech Republic?
Give a very brief answer. 12.64. What is the difference between the highest and the lowest Tax (as % of total tax revenue) of Ethiopia?
Your response must be concise. 15.82. What is the difference between the highest and the lowest Tax (as % of total tax revenue) in Maldives?
Ensure brevity in your answer.  4.15. 